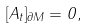<formula> <loc_0><loc_0><loc_500><loc_500>[ A _ { t } ] _ { \partial M } = 0 ,</formula> 